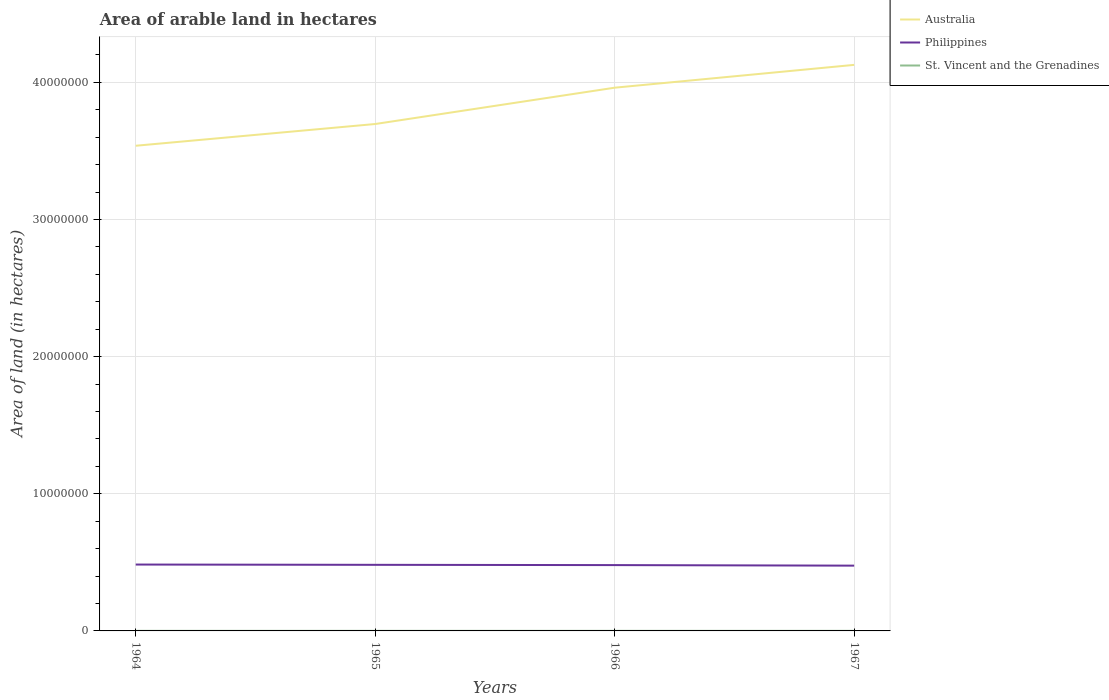Does the line corresponding to Philippines intersect with the line corresponding to Australia?
Give a very brief answer. No. Across all years, what is the maximum total arable land in Australia?
Provide a succinct answer. 3.54e+07. In which year was the total arable land in Australia maximum?
Your answer should be compact. 1964. What is the total total arable land in Philippines in the graph?
Provide a short and direct response. 6.00e+04. What is the difference between the highest and the second highest total arable land in Australia?
Your answer should be very brief. 5.90e+06. How many years are there in the graph?
Keep it short and to the point. 4. What is the difference between two consecutive major ticks on the Y-axis?
Your response must be concise. 1.00e+07. Does the graph contain grids?
Provide a succinct answer. Yes. What is the title of the graph?
Keep it short and to the point. Area of arable land in hectares. What is the label or title of the Y-axis?
Provide a succinct answer. Area of land (in hectares). What is the Area of land (in hectares) of Australia in 1964?
Ensure brevity in your answer.  3.54e+07. What is the Area of land (in hectares) in Philippines in 1964?
Your answer should be very brief. 4.84e+06. What is the Area of land (in hectares) of St. Vincent and the Grenadines in 1964?
Offer a very short reply. 6000. What is the Area of land (in hectares) of Australia in 1965?
Your response must be concise. 3.70e+07. What is the Area of land (in hectares) in Philippines in 1965?
Keep it short and to the point. 4.82e+06. What is the Area of land (in hectares) of St. Vincent and the Grenadines in 1965?
Your answer should be compact. 6000. What is the Area of land (in hectares) in Australia in 1966?
Your answer should be very brief. 3.96e+07. What is the Area of land (in hectares) in Philippines in 1966?
Give a very brief answer. 4.80e+06. What is the Area of land (in hectares) of St. Vincent and the Grenadines in 1966?
Offer a very short reply. 6000. What is the Area of land (in hectares) in Australia in 1967?
Provide a short and direct response. 4.13e+07. What is the Area of land (in hectares) in Philippines in 1967?
Offer a very short reply. 4.76e+06. What is the Area of land (in hectares) in St. Vincent and the Grenadines in 1967?
Make the answer very short. 6000. Across all years, what is the maximum Area of land (in hectares) of Australia?
Give a very brief answer. 4.13e+07. Across all years, what is the maximum Area of land (in hectares) of Philippines?
Keep it short and to the point. 4.84e+06. Across all years, what is the maximum Area of land (in hectares) of St. Vincent and the Grenadines?
Your answer should be very brief. 6000. Across all years, what is the minimum Area of land (in hectares) in Australia?
Ensure brevity in your answer.  3.54e+07. Across all years, what is the minimum Area of land (in hectares) in Philippines?
Provide a succinct answer. 4.76e+06. Across all years, what is the minimum Area of land (in hectares) of St. Vincent and the Grenadines?
Your answer should be very brief. 6000. What is the total Area of land (in hectares) in Australia in the graph?
Ensure brevity in your answer.  1.53e+08. What is the total Area of land (in hectares) in Philippines in the graph?
Give a very brief answer. 1.92e+07. What is the total Area of land (in hectares) of St. Vincent and the Grenadines in the graph?
Provide a short and direct response. 2.40e+04. What is the difference between the Area of land (in hectares) in Australia in 1964 and that in 1965?
Provide a short and direct response. -1.59e+06. What is the difference between the Area of land (in hectares) of St. Vincent and the Grenadines in 1964 and that in 1965?
Offer a terse response. 0. What is the difference between the Area of land (in hectares) of Australia in 1964 and that in 1966?
Your response must be concise. -4.23e+06. What is the difference between the Area of land (in hectares) in Philippines in 1964 and that in 1966?
Keep it short and to the point. 4.00e+04. What is the difference between the Area of land (in hectares) of Australia in 1964 and that in 1967?
Keep it short and to the point. -5.90e+06. What is the difference between the Area of land (in hectares) of St. Vincent and the Grenadines in 1964 and that in 1967?
Your answer should be very brief. 0. What is the difference between the Area of land (in hectares) of Australia in 1965 and that in 1966?
Give a very brief answer. -2.65e+06. What is the difference between the Area of land (in hectares) in Philippines in 1965 and that in 1966?
Your answer should be very brief. 2.00e+04. What is the difference between the Area of land (in hectares) of St. Vincent and the Grenadines in 1965 and that in 1966?
Make the answer very short. 0. What is the difference between the Area of land (in hectares) of Australia in 1965 and that in 1967?
Your answer should be very brief. -4.31e+06. What is the difference between the Area of land (in hectares) in Philippines in 1965 and that in 1967?
Your answer should be compact. 6.00e+04. What is the difference between the Area of land (in hectares) in Australia in 1966 and that in 1967?
Your answer should be compact. -1.66e+06. What is the difference between the Area of land (in hectares) of Australia in 1964 and the Area of land (in hectares) of Philippines in 1965?
Your answer should be compact. 3.06e+07. What is the difference between the Area of land (in hectares) of Australia in 1964 and the Area of land (in hectares) of St. Vincent and the Grenadines in 1965?
Offer a very short reply. 3.54e+07. What is the difference between the Area of land (in hectares) of Philippines in 1964 and the Area of land (in hectares) of St. Vincent and the Grenadines in 1965?
Ensure brevity in your answer.  4.83e+06. What is the difference between the Area of land (in hectares) in Australia in 1964 and the Area of land (in hectares) in Philippines in 1966?
Keep it short and to the point. 3.06e+07. What is the difference between the Area of land (in hectares) of Australia in 1964 and the Area of land (in hectares) of St. Vincent and the Grenadines in 1966?
Ensure brevity in your answer.  3.54e+07. What is the difference between the Area of land (in hectares) of Philippines in 1964 and the Area of land (in hectares) of St. Vincent and the Grenadines in 1966?
Your answer should be very brief. 4.83e+06. What is the difference between the Area of land (in hectares) of Australia in 1964 and the Area of land (in hectares) of Philippines in 1967?
Provide a succinct answer. 3.06e+07. What is the difference between the Area of land (in hectares) in Australia in 1964 and the Area of land (in hectares) in St. Vincent and the Grenadines in 1967?
Your answer should be compact. 3.54e+07. What is the difference between the Area of land (in hectares) of Philippines in 1964 and the Area of land (in hectares) of St. Vincent and the Grenadines in 1967?
Give a very brief answer. 4.83e+06. What is the difference between the Area of land (in hectares) in Australia in 1965 and the Area of land (in hectares) in Philippines in 1966?
Offer a terse response. 3.22e+07. What is the difference between the Area of land (in hectares) of Australia in 1965 and the Area of land (in hectares) of St. Vincent and the Grenadines in 1966?
Provide a short and direct response. 3.70e+07. What is the difference between the Area of land (in hectares) of Philippines in 1965 and the Area of land (in hectares) of St. Vincent and the Grenadines in 1966?
Keep it short and to the point. 4.81e+06. What is the difference between the Area of land (in hectares) in Australia in 1965 and the Area of land (in hectares) in Philippines in 1967?
Make the answer very short. 3.22e+07. What is the difference between the Area of land (in hectares) of Australia in 1965 and the Area of land (in hectares) of St. Vincent and the Grenadines in 1967?
Offer a terse response. 3.70e+07. What is the difference between the Area of land (in hectares) in Philippines in 1965 and the Area of land (in hectares) in St. Vincent and the Grenadines in 1967?
Your answer should be very brief. 4.81e+06. What is the difference between the Area of land (in hectares) of Australia in 1966 and the Area of land (in hectares) of Philippines in 1967?
Make the answer very short. 3.49e+07. What is the difference between the Area of land (in hectares) in Australia in 1966 and the Area of land (in hectares) in St. Vincent and the Grenadines in 1967?
Your response must be concise. 3.96e+07. What is the difference between the Area of land (in hectares) in Philippines in 1966 and the Area of land (in hectares) in St. Vincent and the Grenadines in 1967?
Ensure brevity in your answer.  4.79e+06. What is the average Area of land (in hectares) of Australia per year?
Provide a succinct answer. 3.83e+07. What is the average Area of land (in hectares) in Philippines per year?
Ensure brevity in your answer.  4.80e+06. What is the average Area of land (in hectares) of St. Vincent and the Grenadines per year?
Give a very brief answer. 6000. In the year 1964, what is the difference between the Area of land (in hectares) of Australia and Area of land (in hectares) of Philippines?
Your answer should be very brief. 3.05e+07. In the year 1964, what is the difference between the Area of land (in hectares) in Australia and Area of land (in hectares) in St. Vincent and the Grenadines?
Provide a succinct answer. 3.54e+07. In the year 1964, what is the difference between the Area of land (in hectares) of Philippines and Area of land (in hectares) of St. Vincent and the Grenadines?
Make the answer very short. 4.83e+06. In the year 1965, what is the difference between the Area of land (in hectares) in Australia and Area of land (in hectares) in Philippines?
Ensure brevity in your answer.  3.21e+07. In the year 1965, what is the difference between the Area of land (in hectares) of Australia and Area of land (in hectares) of St. Vincent and the Grenadines?
Your answer should be compact. 3.70e+07. In the year 1965, what is the difference between the Area of land (in hectares) in Philippines and Area of land (in hectares) in St. Vincent and the Grenadines?
Your response must be concise. 4.81e+06. In the year 1966, what is the difference between the Area of land (in hectares) in Australia and Area of land (in hectares) in Philippines?
Provide a succinct answer. 3.48e+07. In the year 1966, what is the difference between the Area of land (in hectares) in Australia and Area of land (in hectares) in St. Vincent and the Grenadines?
Your answer should be very brief. 3.96e+07. In the year 1966, what is the difference between the Area of land (in hectares) in Philippines and Area of land (in hectares) in St. Vincent and the Grenadines?
Give a very brief answer. 4.79e+06. In the year 1967, what is the difference between the Area of land (in hectares) in Australia and Area of land (in hectares) in Philippines?
Your answer should be very brief. 3.65e+07. In the year 1967, what is the difference between the Area of land (in hectares) in Australia and Area of land (in hectares) in St. Vincent and the Grenadines?
Your answer should be compact. 4.13e+07. In the year 1967, what is the difference between the Area of land (in hectares) in Philippines and Area of land (in hectares) in St. Vincent and the Grenadines?
Your response must be concise. 4.75e+06. What is the ratio of the Area of land (in hectares) in Australia in 1964 to that in 1965?
Your answer should be compact. 0.96. What is the ratio of the Area of land (in hectares) in Philippines in 1964 to that in 1965?
Give a very brief answer. 1. What is the ratio of the Area of land (in hectares) of Australia in 1964 to that in 1966?
Keep it short and to the point. 0.89. What is the ratio of the Area of land (in hectares) of Philippines in 1964 to that in 1966?
Offer a terse response. 1.01. What is the ratio of the Area of land (in hectares) in Philippines in 1964 to that in 1967?
Offer a very short reply. 1.02. What is the ratio of the Area of land (in hectares) of Australia in 1965 to that in 1966?
Make the answer very short. 0.93. What is the ratio of the Area of land (in hectares) of St. Vincent and the Grenadines in 1965 to that in 1966?
Keep it short and to the point. 1. What is the ratio of the Area of land (in hectares) in Australia in 1965 to that in 1967?
Keep it short and to the point. 0.9. What is the ratio of the Area of land (in hectares) of Philippines in 1965 to that in 1967?
Your response must be concise. 1.01. What is the ratio of the Area of land (in hectares) in St. Vincent and the Grenadines in 1965 to that in 1967?
Your answer should be very brief. 1. What is the ratio of the Area of land (in hectares) of Australia in 1966 to that in 1967?
Keep it short and to the point. 0.96. What is the ratio of the Area of land (in hectares) in Philippines in 1966 to that in 1967?
Give a very brief answer. 1.01. What is the difference between the highest and the second highest Area of land (in hectares) in Australia?
Your answer should be compact. 1.66e+06. What is the difference between the highest and the second highest Area of land (in hectares) of Philippines?
Make the answer very short. 2.00e+04. What is the difference between the highest and the lowest Area of land (in hectares) of Australia?
Offer a very short reply. 5.90e+06. What is the difference between the highest and the lowest Area of land (in hectares) in Philippines?
Your response must be concise. 8.00e+04. What is the difference between the highest and the lowest Area of land (in hectares) in St. Vincent and the Grenadines?
Your answer should be compact. 0. 